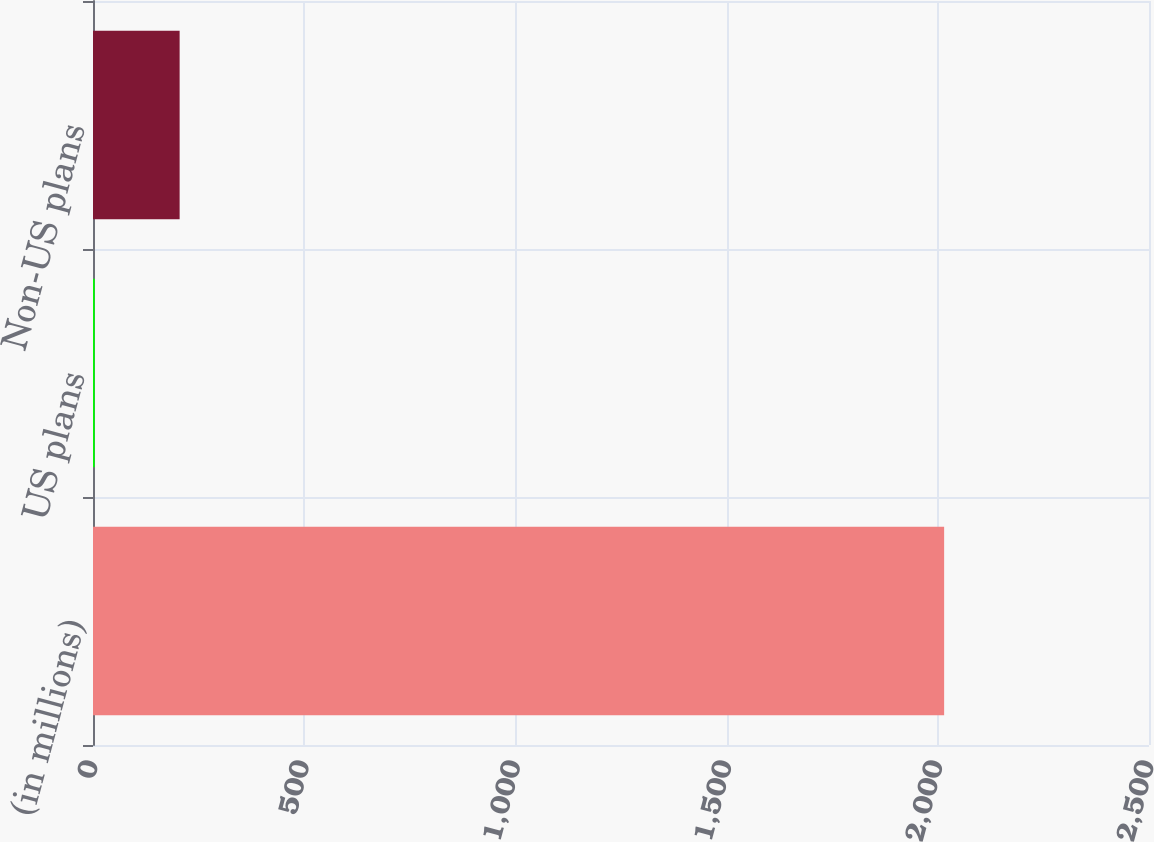<chart> <loc_0><loc_0><loc_500><loc_500><bar_chart><fcel>(in millions)<fcel>US plans<fcel>Non-US plans<nl><fcel>2015<fcel>4<fcel>205.1<nl></chart> 